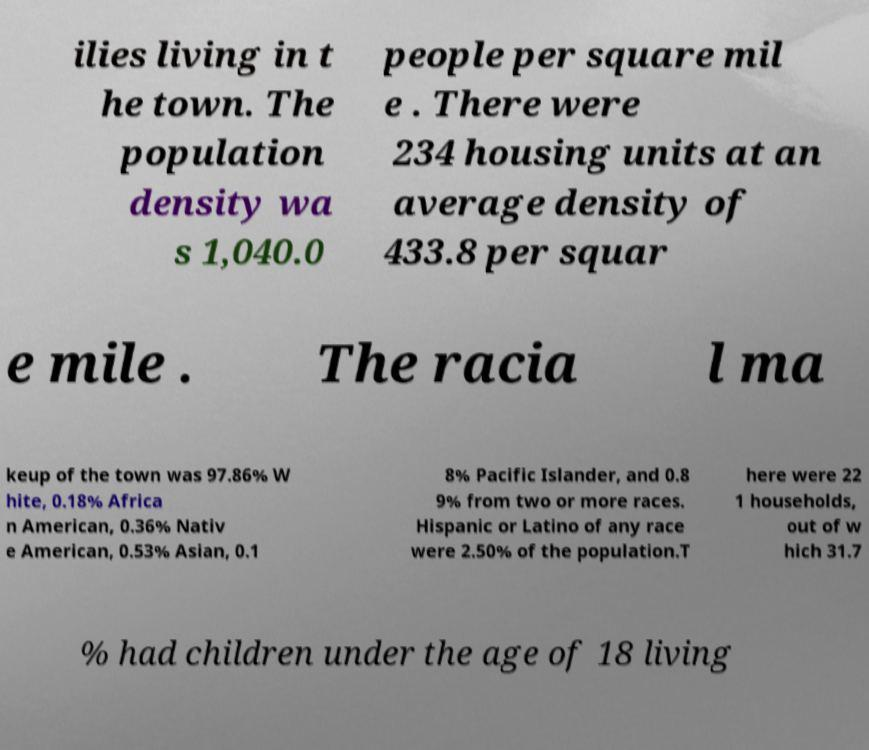Could you assist in decoding the text presented in this image and type it out clearly? ilies living in t he town. The population density wa s 1,040.0 people per square mil e . There were 234 housing units at an average density of 433.8 per squar e mile . The racia l ma keup of the town was 97.86% W hite, 0.18% Africa n American, 0.36% Nativ e American, 0.53% Asian, 0.1 8% Pacific Islander, and 0.8 9% from two or more races. Hispanic or Latino of any race were 2.50% of the population.T here were 22 1 households, out of w hich 31.7 % had children under the age of 18 living 